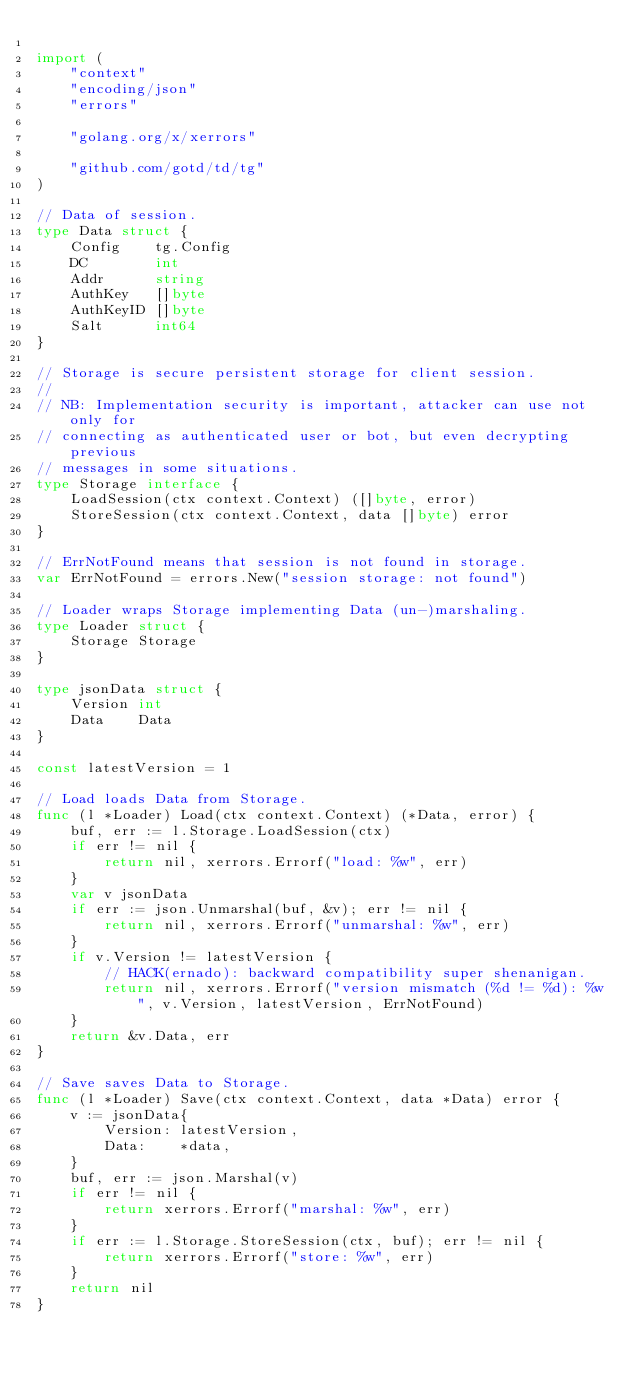<code> <loc_0><loc_0><loc_500><loc_500><_Go_>
import (
	"context"
	"encoding/json"
	"errors"

	"golang.org/x/xerrors"

	"github.com/gotd/td/tg"
)

// Data of session.
type Data struct {
	Config    tg.Config
	DC        int
	Addr      string
	AuthKey   []byte
	AuthKeyID []byte
	Salt      int64
}

// Storage is secure persistent storage for client session.
//
// NB: Implementation security is important, attacker can use not only for
// connecting as authenticated user or bot, but even decrypting previous
// messages in some situations.
type Storage interface {
	LoadSession(ctx context.Context) ([]byte, error)
	StoreSession(ctx context.Context, data []byte) error
}

// ErrNotFound means that session is not found in storage.
var ErrNotFound = errors.New("session storage: not found")

// Loader wraps Storage implementing Data (un-)marshaling.
type Loader struct {
	Storage Storage
}

type jsonData struct {
	Version int
	Data    Data
}

const latestVersion = 1

// Load loads Data from Storage.
func (l *Loader) Load(ctx context.Context) (*Data, error) {
	buf, err := l.Storage.LoadSession(ctx)
	if err != nil {
		return nil, xerrors.Errorf("load: %w", err)
	}
	var v jsonData
	if err := json.Unmarshal(buf, &v); err != nil {
		return nil, xerrors.Errorf("unmarshal: %w", err)
	}
	if v.Version != latestVersion {
		// HACK(ernado): backward compatibility super shenanigan.
		return nil, xerrors.Errorf("version mismatch (%d != %d): %w", v.Version, latestVersion, ErrNotFound)
	}
	return &v.Data, err
}

// Save saves Data to Storage.
func (l *Loader) Save(ctx context.Context, data *Data) error {
	v := jsonData{
		Version: latestVersion,
		Data:    *data,
	}
	buf, err := json.Marshal(v)
	if err != nil {
		return xerrors.Errorf("marshal: %w", err)
	}
	if err := l.Storage.StoreSession(ctx, buf); err != nil {
		return xerrors.Errorf("store: %w", err)
	}
	return nil
}
</code> 